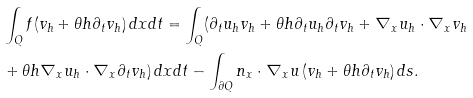Convert formula to latex. <formula><loc_0><loc_0><loc_500><loc_500>& \int _ { Q } f ( v _ { h } + \theta h \partial _ { t } v _ { h } ) \, d x d t = \int _ { Q } ( \partial _ { t } u _ { h } v _ { h } + \theta h \partial _ { t } u _ { h } \partial _ { t } v _ { h } + \nabla _ { x } u _ { h } \cdot \nabla _ { x } v _ { h } \\ & + \theta h \nabla _ { x } u _ { h } \cdot \nabla _ { x } \partial _ { t } v _ { h } ) \, d x d t - \int _ { \partial Q } n _ { x } \cdot \nabla _ { x } u \, ( v _ { h } + \theta h \partial _ { t } v _ { h } ) \, d s .</formula> 